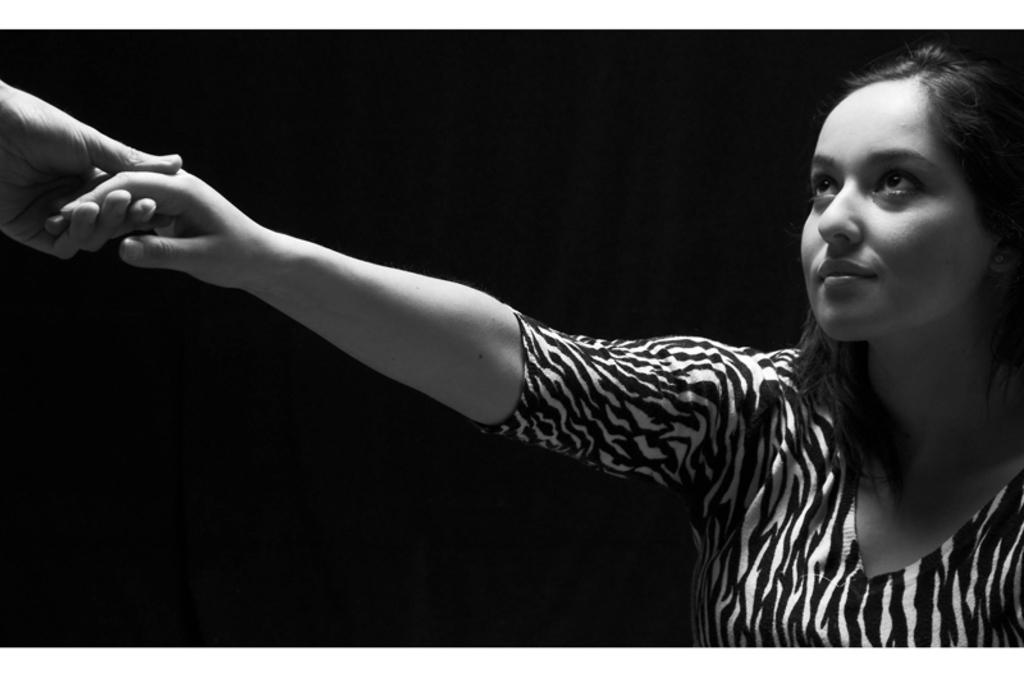What type of picture is in the image? The image contains a black and white picture of a woman. What can be observed about the woman's attire in the picture? The woman is wearing clothes in the picture. Whose hand is visible in the image? There is a hand of another person visible in the image. How would you describe the background of the picture? The background of the image is blurred. What type of wax can be seen melting in the image? There is no wax present in the image; it contains a black and white picture of a woman. How many flowers are visible in the image? There are no flowers visible in the image. 